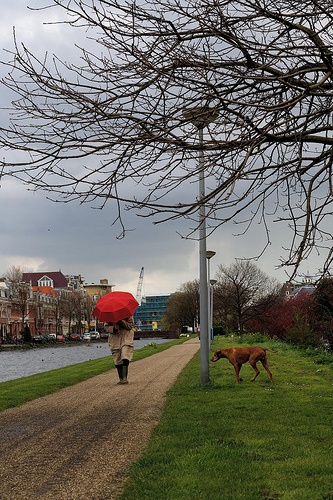Describe the objects in this image and their specific colors. I can see umbrella in lightgray, maroon, brown, and black tones, people in lightgray, black, gray, and maroon tones, dog in lightgray, maroon, black, olive, and brown tones, car in lightgray, black, gray, and darkgray tones, and car in lightgray, black, gray, maroon, and brown tones in this image. 